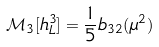Convert formula to latex. <formula><loc_0><loc_0><loc_500><loc_500>\mathcal { M } _ { 3 } [ h _ { L } ^ { 3 } ] = \frac { 1 } { 5 } b _ { 3 2 } ( \mu ^ { 2 } )</formula> 